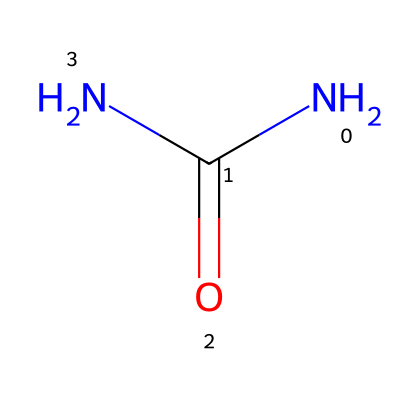What is the molecular formula of this chemical? The chemical structure has one nitrogen (N) and two carbon (C) atoms with four oxygen (O) atoms visually combined in the SMILES representation. By counting each atom as indicated in the structure, we identify the molecular formula: C2H4N2O.
Answer: C2H4N2O How many total atoms are present in this chemical? In the given structure, we observe that there are 2 carbon (C) atoms, 4 hydrogen (H) atoms, and 2 nitrogen (N) atoms for a total of 8 atoms. Thus, we sum them: 2 (C) + 4 (H) + 2 (N) = 8 atoms.
Answer: 8 What functional group is identified in this structure? The SMILES representation clearly denotes the presence of an amide functional group indicated by the carbonyl (C=O) connected to a nitrogen atom (N). This combination is characteristic of an amide, which is typically formed between a carboxylic acid and an amine.
Answer: amide Is this chemical commonly used in skin-care products? Yes, the chemical structure revealed corresponds to urea, which is frequently utilized in the formulation of moisturizing products due to its ability to retain moisture in the skin.
Answer: yes How many double bonds are present in this molecule? In the structure, we can identify only one double bond associated with the carbonyl group (C=O) attached to the nitrogen (N), indicating the presence of one double bond in the entire molecule.
Answer: one What is the role of this chemical in skin hydration? The chemical structure represents components of natural moisturizing factors like urea, which helps to absorb and retain moisture in the skin, effectively acting as a humectant in skin-care products.
Answer: humectant Does this chemical contain any carbon atoms? The structure indicates two carbon (C) atoms present in the chemical formula. This information is explicitly shown in the SMILES notation providing a clear count of the carbon atoms.
Answer: yes 